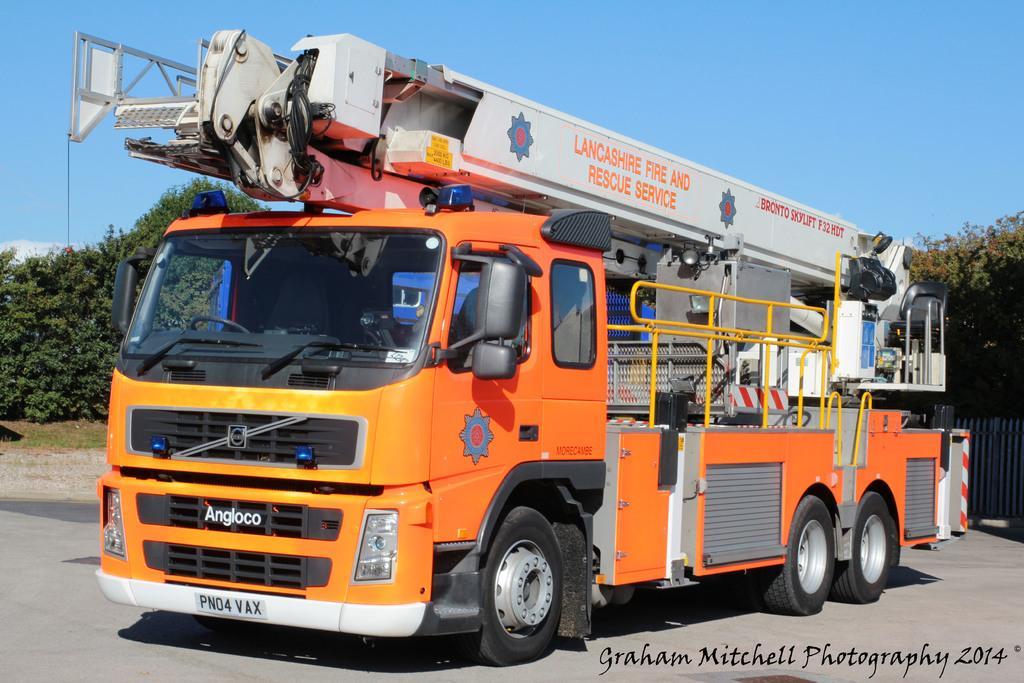In one or two sentences, can you explain what this image depicts? In this image we can see a truck. On the truck there are logos and text. In the background there are trees. Also there is a fencing. And there is sky. At the bottom there is text. 